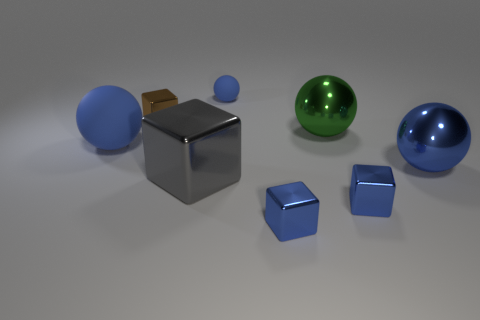Subtract all blue balls. How many balls are left? 1 Add 1 tiny brown things. How many objects exist? 9 Subtract all brown cubes. How many cubes are left? 3 Subtract 3 cubes. How many cubes are left? 1 Subtract all purple blocks. How many green balls are left? 1 Add 7 tiny blue matte spheres. How many tiny blue matte spheres are left? 8 Add 2 brown metal things. How many brown metal things exist? 3 Subtract 0 red balls. How many objects are left? 8 Subtract all green balls. Subtract all red cubes. How many balls are left? 3 Subtract all big gray metal objects. Subtract all big rubber balls. How many objects are left? 6 